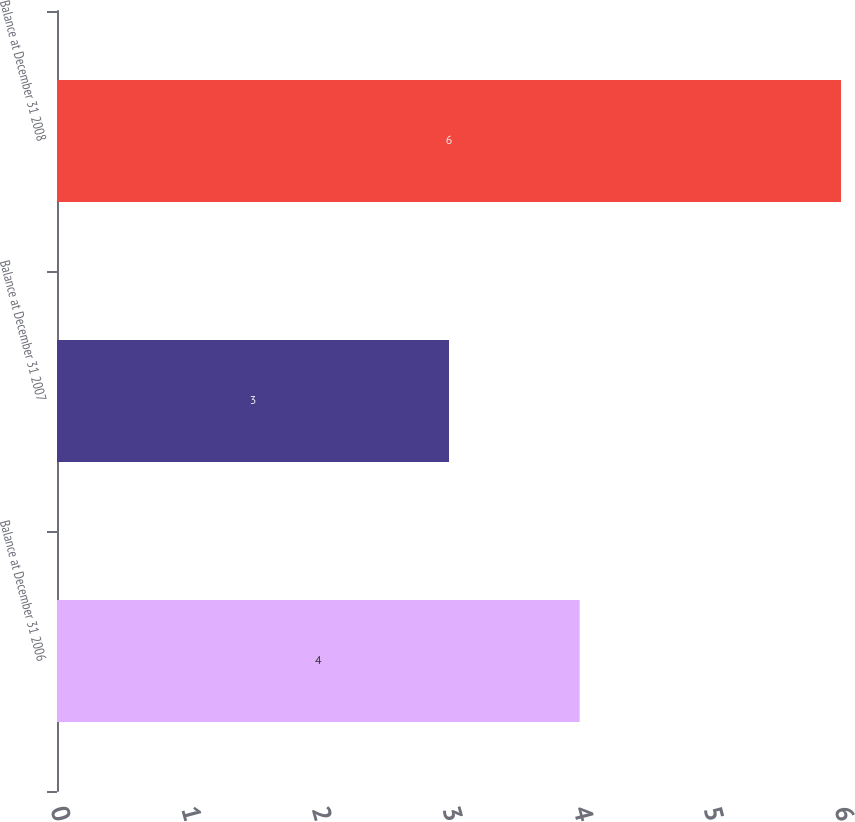Convert chart to OTSL. <chart><loc_0><loc_0><loc_500><loc_500><bar_chart><fcel>Balance at December 31 2006<fcel>Balance at December 31 2007<fcel>Balance at December 31 2008<nl><fcel>4<fcel>3<fcel>6<nl></chart> 